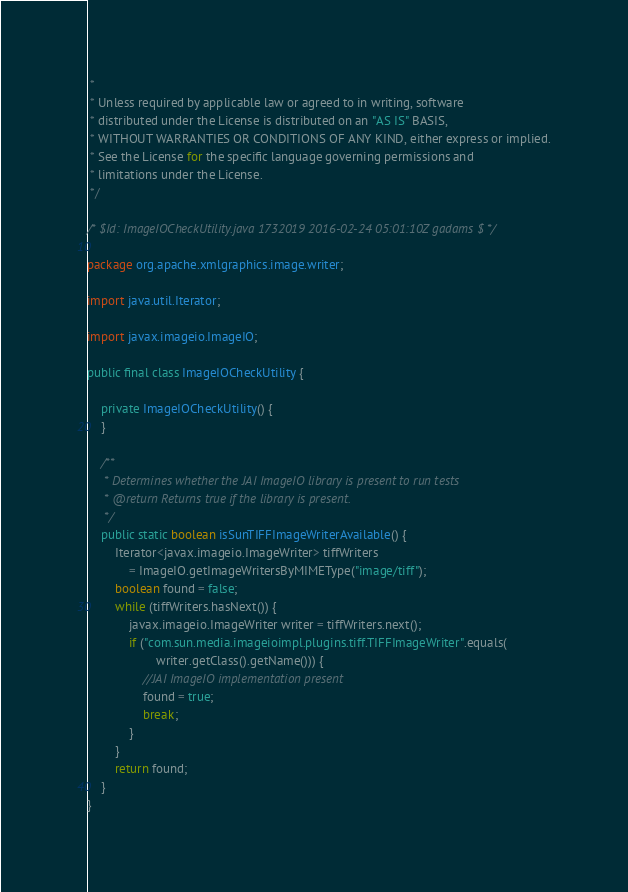Convert code to text. <code><loc_0><loc_0><loc_500><loc_500><_Java_> *
 * Unless required by applicable law or agreed to in writing, software
 * distributed under the License is distributed on an "AS IS" BASIS,
 * WITHOUT WARRANTIES OR CONDITIONS OF ANY KIND, either express or implied.
 * See the License for the specific language governing permissions and
 * limitations under the License.
 */

/* $Id: ImageIOCheckUtility.java 1732019 2016-02-24 05:01:10Z gadams $ */

package org.apache.xmlgraphics.image.writer;

import java.util.Iterator;

import javax.imageio.ImageIO;

public final class ImageIOCheckUtility {

    private ImageIOCheckUtility() {
    }

    /**
     * Determines whether the JAI ImageIO library is present to run tests
     * @return Returns true if the library is present.
     */
    public static boolean isSunTIFFImageWriterAvailable() {
        Iterator<javax.imageio.ImageWriter> tiffWriters
            = ImageIO.getImageWritersByMIMEType("image/tiff");
        boolean found = false;
        while (tiffWriters.hasNext()) {
            javax.imageio.ImageWriter writer = tiffWriters.next();
            if ("com.sun.media.imageioimpl.plugins.tiff.TIFFImageWriter".equals(
                    writer.getClass().getName())) {
                //JAI ImageIO implementation present
                found = true;
                break;
            }
        }
        return found;
    }
}
</code> 